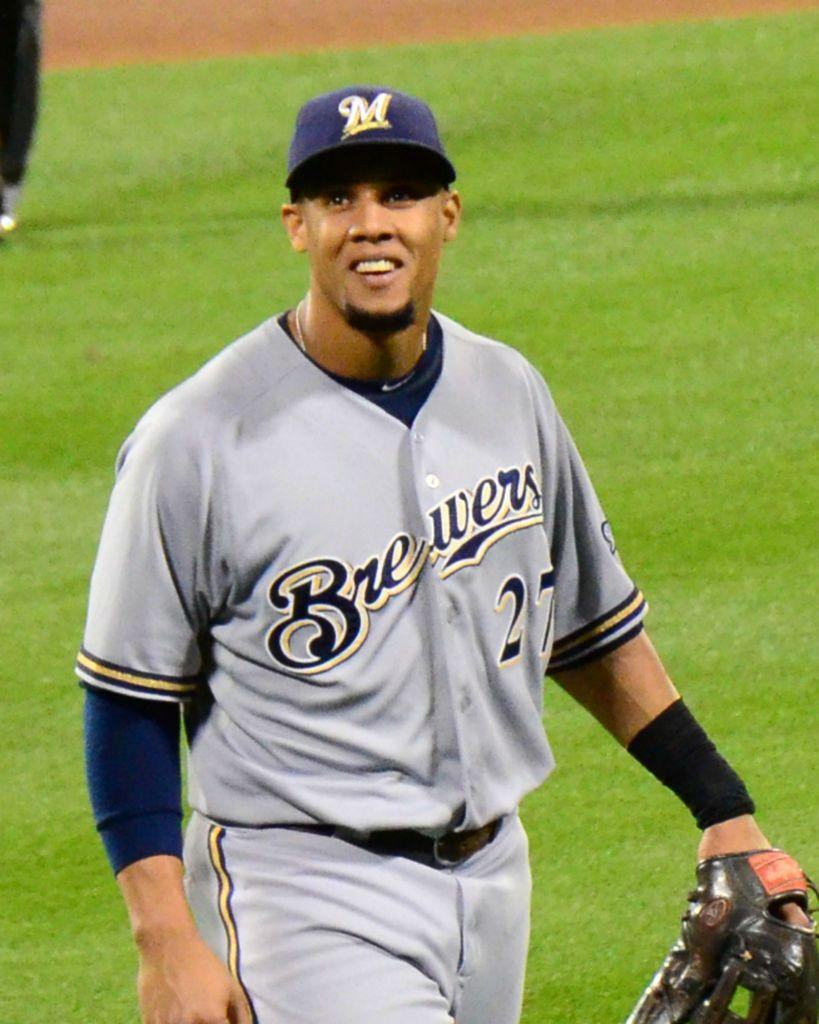<image>
Relay a brief, clear account of the picture shown. Number 27 for the Brewers is right handed. 